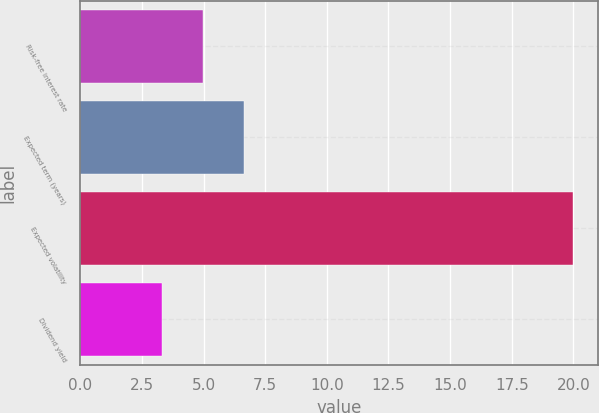Convert chart to OTSL. <chart><loc_0><loc_0><loc_500><loc_500><bar_chart><fcel>Risk-free interest rate<fcel>Expected term (years)<fcel>Expected volatility<fcel>Dividend yield<nl><fcel>4.97<fcel>6.64<fcel>20<fcel>3.3<nl></chart> 